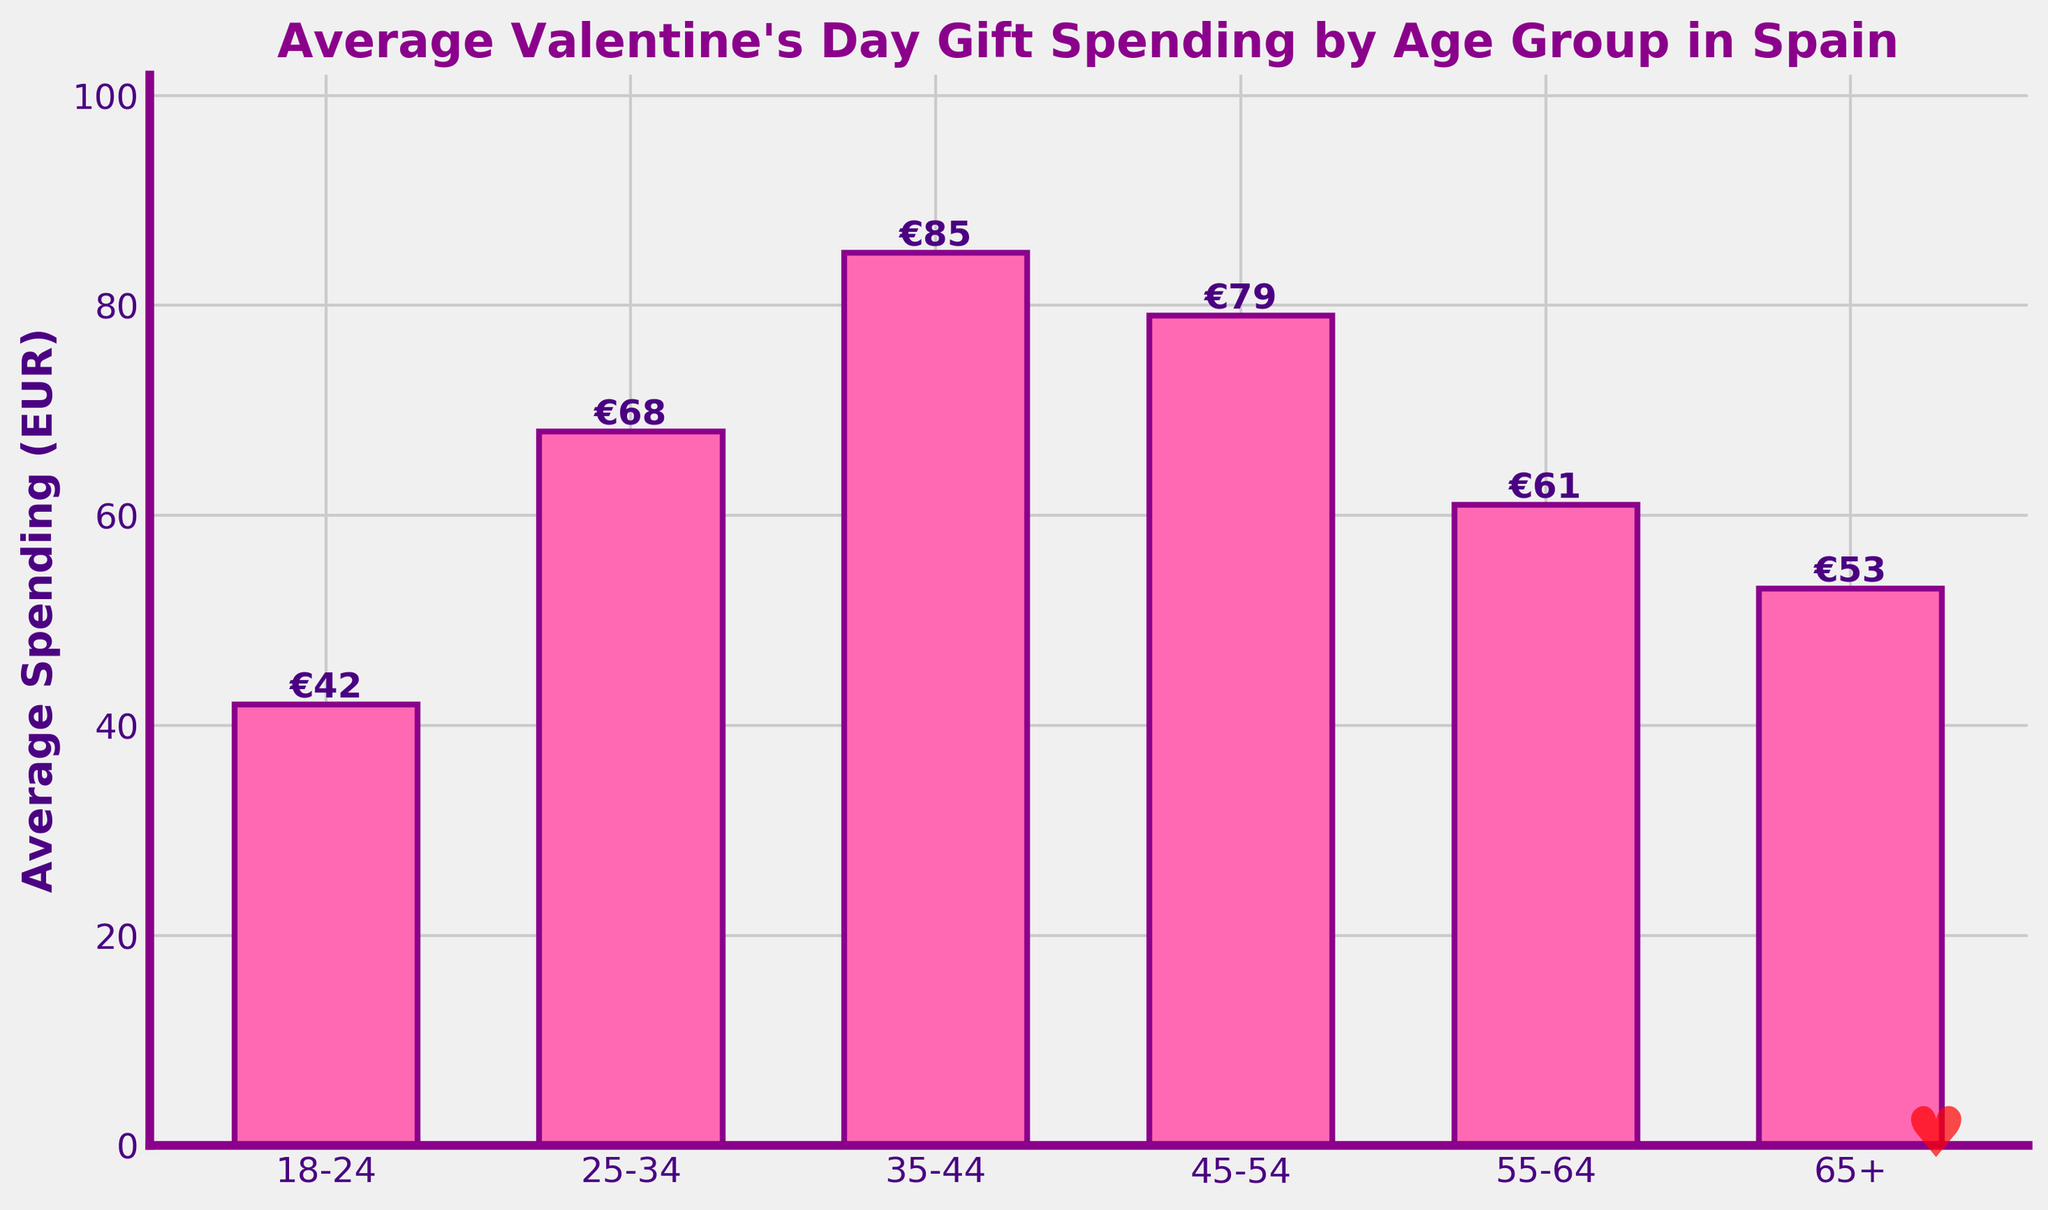What's the average spending for people aged 25-34? The bar for the 25-34 age group shows a spending amount of €68. Since it is the only value provided, the average spending for this group directly refers to this amount.
Answer: €68 Which age group spends the most on Valentine's Day gifts? The highest bar represents the 35-44 age group with an average spending of €85. Visually compare the heights of all the bars to determine this.
Answer: 35-44 How much more do people aged 35-44 spend compared to those aged 65+? The bar for the 35-44 age group shows €85, and the bar for 65+ shows €53. The difference is calculated as €85 - €53.
Answer: €32 What is the total average spending of the age groups from 18-24 and 25-34? The bar for the 18-24 group shows €42, and the bar for the 25-34 group shows €68. Sum these values to find the total average spending: €42 + €68.
Answer: €110 Is the average spending of the 45-54 age group higher than that of the 55-64 age group? Visually compare the bars for the 45-54 and 55-64 age groups. The 45-54 group shows €79, and the 55-64 group shows €61. Since €79 is higher than €61, the average spending is higher for the 45-54 age group.
Answer: Yes Which age groups spend less than €60 on average? Identify the bars with heights that correspond to values less than €60. The bars for the 18-24 and 65+ age groups show €42 and €53 respectively, both below €60.
Answer: 18-24 and 65+ What is the percentage increase in average spending from the age group 18-24 to the age group 25-34? Calculate the increase in spending from €42 (18-24) to €68 (25-34), which is €68 - €42 = €26. Then, calculate the percentage increase: (€26 / €42) * 100.
Answer: 61.9% Order the age groups by their average spending from highest to lowest. Visually compare and list the height of the bars: 
1. 35-44 (€85) 
2. 45-54 (€79) 
3. 25-34 (€68) 
4. 55-64 (€61) 
5. 65+ (€53) 
6. 18-24 (€42).
Answer: 35-44, 45-54, 25-34, 55-64, 65+, 18-24 What is the range of the average spending on Valentine's Day gifts across all age groups? Determine the difference between the maximum and minimum values from the bars. The maximum is €85 (35-44) and the minimum is €42 (18-24). The range is calculated as €85 - €42.
Answer: €43 